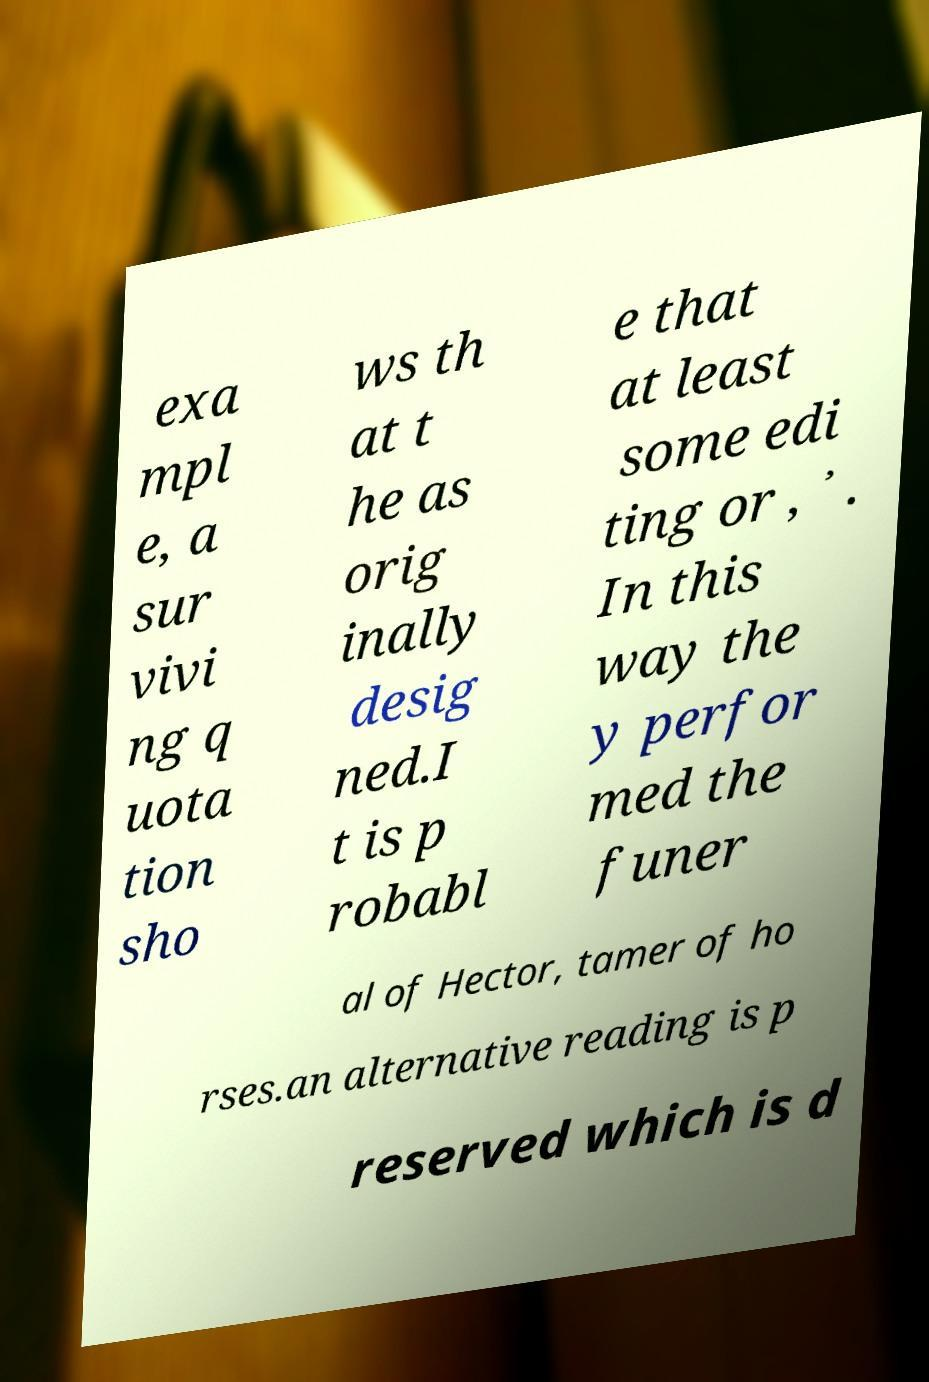I need the written content from this picture converted into text. Can you do that? exa mpl e, a sur vivi ng q uota tion sho ws th at t he as orig inally desig ned.I t is p robabl e that at least some edi ting or , ᾽ . In this way the y perfor med the funer al of Hector, tamer of ho rses.an alternative reading is p reserved which is d 